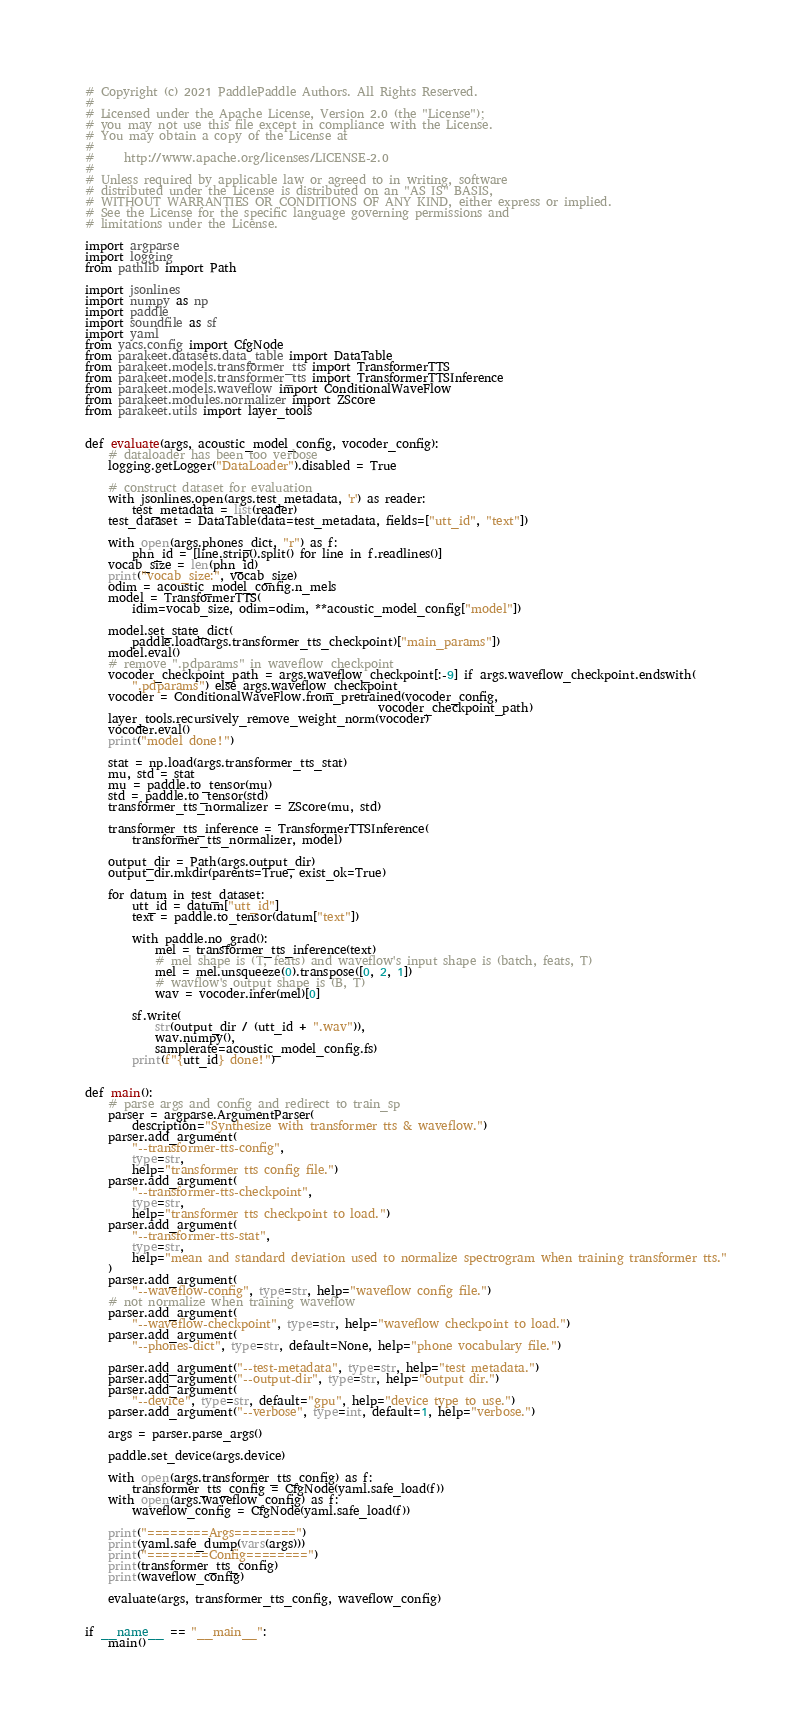Convert code to text. <code><loc_0><loc_0><loc_500><loc_500><_Python_># Copyright (c) 2021 PaddlePaddle Authors. All Rights Reserved.
#
# Licensed under the Apache License, Version 2.0 (the "License");
# you may not use this file except in compliance with the License.
# You may obtain a copy of the License at
#
#     http://www.apache.org/licenses/LICENSE-2.0
#
# Unless required by applicable law or agreed to in writing, software
# distributed under the License is distributed on an "AS IS" BASIS,
# WITHOUT WARRANTIES OR CONDITIONS OF ANY KIND, either express or implied.
# See the License for the specific language governing permissions and
# limitations under the License.

import argparse
import logging
from pathlib import Path

import jsonlines
import numpy as np
import paddle
import soundfile as sf
import yaml
from yacs.config import CfgNode
from parakeet.datasets.data_table import DataTable
from parakeet.models.transformer_tts import TransformerTTS
from parakeet.models.transformer_tts import TransformerTTSInference
from parakeet.models.waveflow import ConditionalWaveFlow
from parakeet.modules.normalizer import ZScore
from parakeet.utils import layer_tools


def evaluate(args, acoustic_model_config, vocoder_config):
    # dataloader has been too verbose
    logging.getLogger("DataLoader").disabled = True

    # construct dataset for evaluation
    with jsonlines.open(args.test_metadata, 'r') as reader:
        test_metadata = list(reader)
    test_dataset = DataTable(data=test_metadata, fields=["utt_id", "text"])

    with open(args.phones_dict, "r") as f:
        phn_id = [line.strip().split() for line in f.readlines()]
    vocab_size = len(phn_id)
    print("vocab_size:", vocab_size)
    odim = acoustic_model_config.n_mels
    model = TransformerTTS(
        idim=vocab_size, odim=odim, **acoustic_model_config["model"])

    model.set_state_dict(
        paddle.load(args.transformer_tts_checkpoint)["main_params"])
    model.eval()
    # remove ".pdparams" in waveflow_checkpoint
    vocoder_checkpoint_path = args.waveflow_checkpoint[:-9] if args.waveflow_checkpoint.endswith(
        ".pdparams") else args.waveflow_checkpoint
    vocoder = ConditionalWaveFlow.from_pretrained(vocoder_config,
                                                  vocoder_checkpoint_path)
    layer_tools.recursively_remove_weight_norm(vocoder)
    vocoder.eval()
    print("model done!")

    stat = np.load(args.transformer_tts_stat)
    mu, std = stat
    mu = paddle.to_tensor(mu)
    std = paddle.to_tensor(std)
    transformer_tts_normalizer = ZScore(mu, std)

    transformer_tts_inference = TransformerTTSInference(
        transformer_tts_normalizer, model)

    output_dir = Path(args.output_dir)
    output_dir.mkdir(parents=True, exist_ok=True)

    for datum in test_dataset:
        utt_id = datum["utt_id"]
        text = paddle.to_tensor(datum["text"])

        with paddle.no_grad():
            mel = transformer_tts_inference(text)
            # mel shape is (T, feats) and waveflow's input shape is (batch, feats, T)
            mel = mel.unsqueeze(0).transpose([0, 2, 1])
            # wavflow's output shape is (B, T)
            wav = vocoder.infer(mel)[0]

        sf.write(
            str(output_dir / (utt_id + ".wav")),
            wav.numpy(),
            samplerate=acoustic_model_config.fs)
        print(f"{utt_id} done!")


def main():
    # parse args and config and redirect to train_sp
    parser = argparse.ArgumentParser(
        description="Synthesize with transformer tts & waveflow.")
    parser.add_argument(
        "--transformer-tts-config",
        type=str,
        help="transformer tts config file.")
    parser.add_argument(
        "--transformer-tts-checkpoint",
        type=str,
        help="transformer tts checkpoint to load.")
    parser.add_argument(
        "--transformer-tts-stat",
        type=str,
        help="mean and standard deviation used to normalize spectrogram when training transformer tts."
    )
    parser.add_argument(
        "--waveflow-config", type=str, help="waveflow config file.")
    # not normalize when training waveflow
    parser.add_argument(
        "--waveflow-checkpoint", type=str, help="waveflow checkpoint to load.")
    parser.add_argument(
        "--phones-dict", type=str, default=None, help="phone vocabulary file.")

    parser.add_argument("--test-metadata", type=str, help="test metadata.")
    parser.add_argument("--output-dir", type=str, help="output dir.")
    parser.add_argument(
        "--device", type=str, default="gpu", help="device type to use.")
    parser.add_argument("--verbose", type=int, default=1, help="verbose.")

    args = parser.parse_args()

    paddle.set_device(args.device)

    with open(args.transformer_tts_config) as f:
        transformer_tts_config = CfgNode(yaml.safe_load(f))
    with open(args.waveflow_config) as f:
        waveflow_config = CfgNode(yaml.safe_load(f))

    print("========Args========")
    print(yaml.safe_dump(vars(args)))
    print("========Config========")
    print(transformer_tts_config)
    print(waveflow_config)

    evaluate(args, transformer_tts_config, waveflow_config)


if __name__ == "__main__":
    main()
</code> 